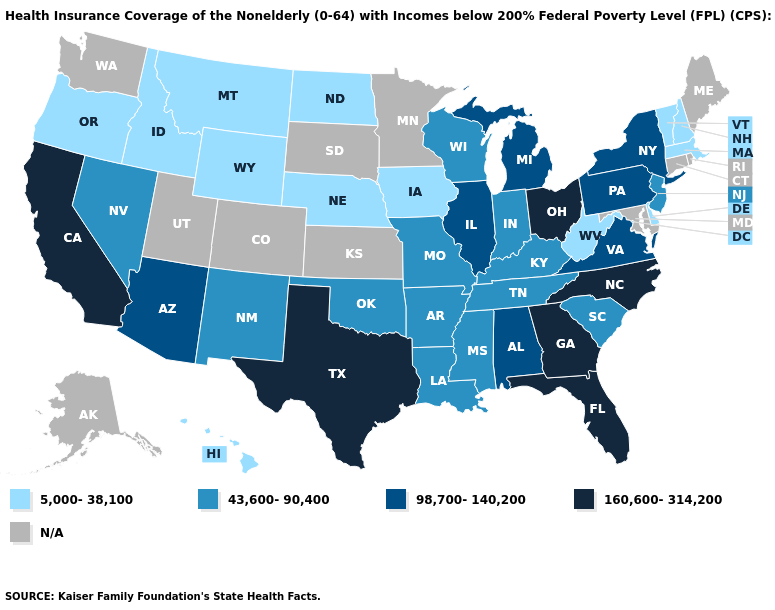Which states hav the highest value in the West?
Write a very short answer. California. Does Mississippi have the lowest value in the USA?
Concise answer only. No. What is the lowest value in the USA?
Short answer required. 5,000-38,100. What is the value of Idaho?
Be succinct. 5,000-38,100. Name the states that have a value in the range 160,600-314,200?
Concise answer only. California, Florida, Georgia, North Carolina, Ohio, Texas. What is the highest value in the South ?
Be succinct. 160,600-314,200. How many symbols are there in the legend?
Keep it brief. 5. Name the states that have a value in the range 43,600-90,400?
Write a very short answer. Arkansas, Indiana, Kentucky, Louisiana, Mississippi, Missouri, Nevada, New Jersey, New Mexico, Oklahoma, South Carolina, Tennessee, Wisconsin. Does the map have missing data?
Write a very short answer. Yes. Name the states that have a value in the range 43,600-90,400?
Write a very short answer. Arkansas, Indiana, Kentucky, Louisiana, Mississippi, Missouri, Nevada, New Jersey, New Mexico, Oklahoma, South Carolina, Tennessee, Wisconsin. Is the legend a continuous bar?
Keep it brief. No. Name the states that have a value in the range N/A?
Concise answer only. Alaska, Colorado, Connecticut, Kansas, Maine, Maryland, Minnesota, Rhode Island, South Dakota, Utah, Washington. Name the states that have a value in the range 98,700-140,200?
Concise answer only. Alabama, Arizona, Illinois, Michigan, New York, Pennsylvania, Virginia. What is the value of Utah?
Short answer required. N/A. What is the value of Alabama?
Keep it brief. 98,700-140,200. 